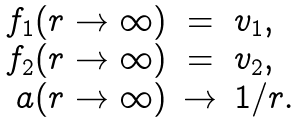<formula> <loc_0><loc_0><loc_500><loc_500>\begin{array} { r c l } f _ { 1 } ( r \to \infty ) & = & v _ { 1 } , \\ f _ { 2 } ( r \to \infty ) & = & v _ { 2 } , \\ a ( r \to \infty ) & \to & 1 / r . \\ \end{array}</formula> 